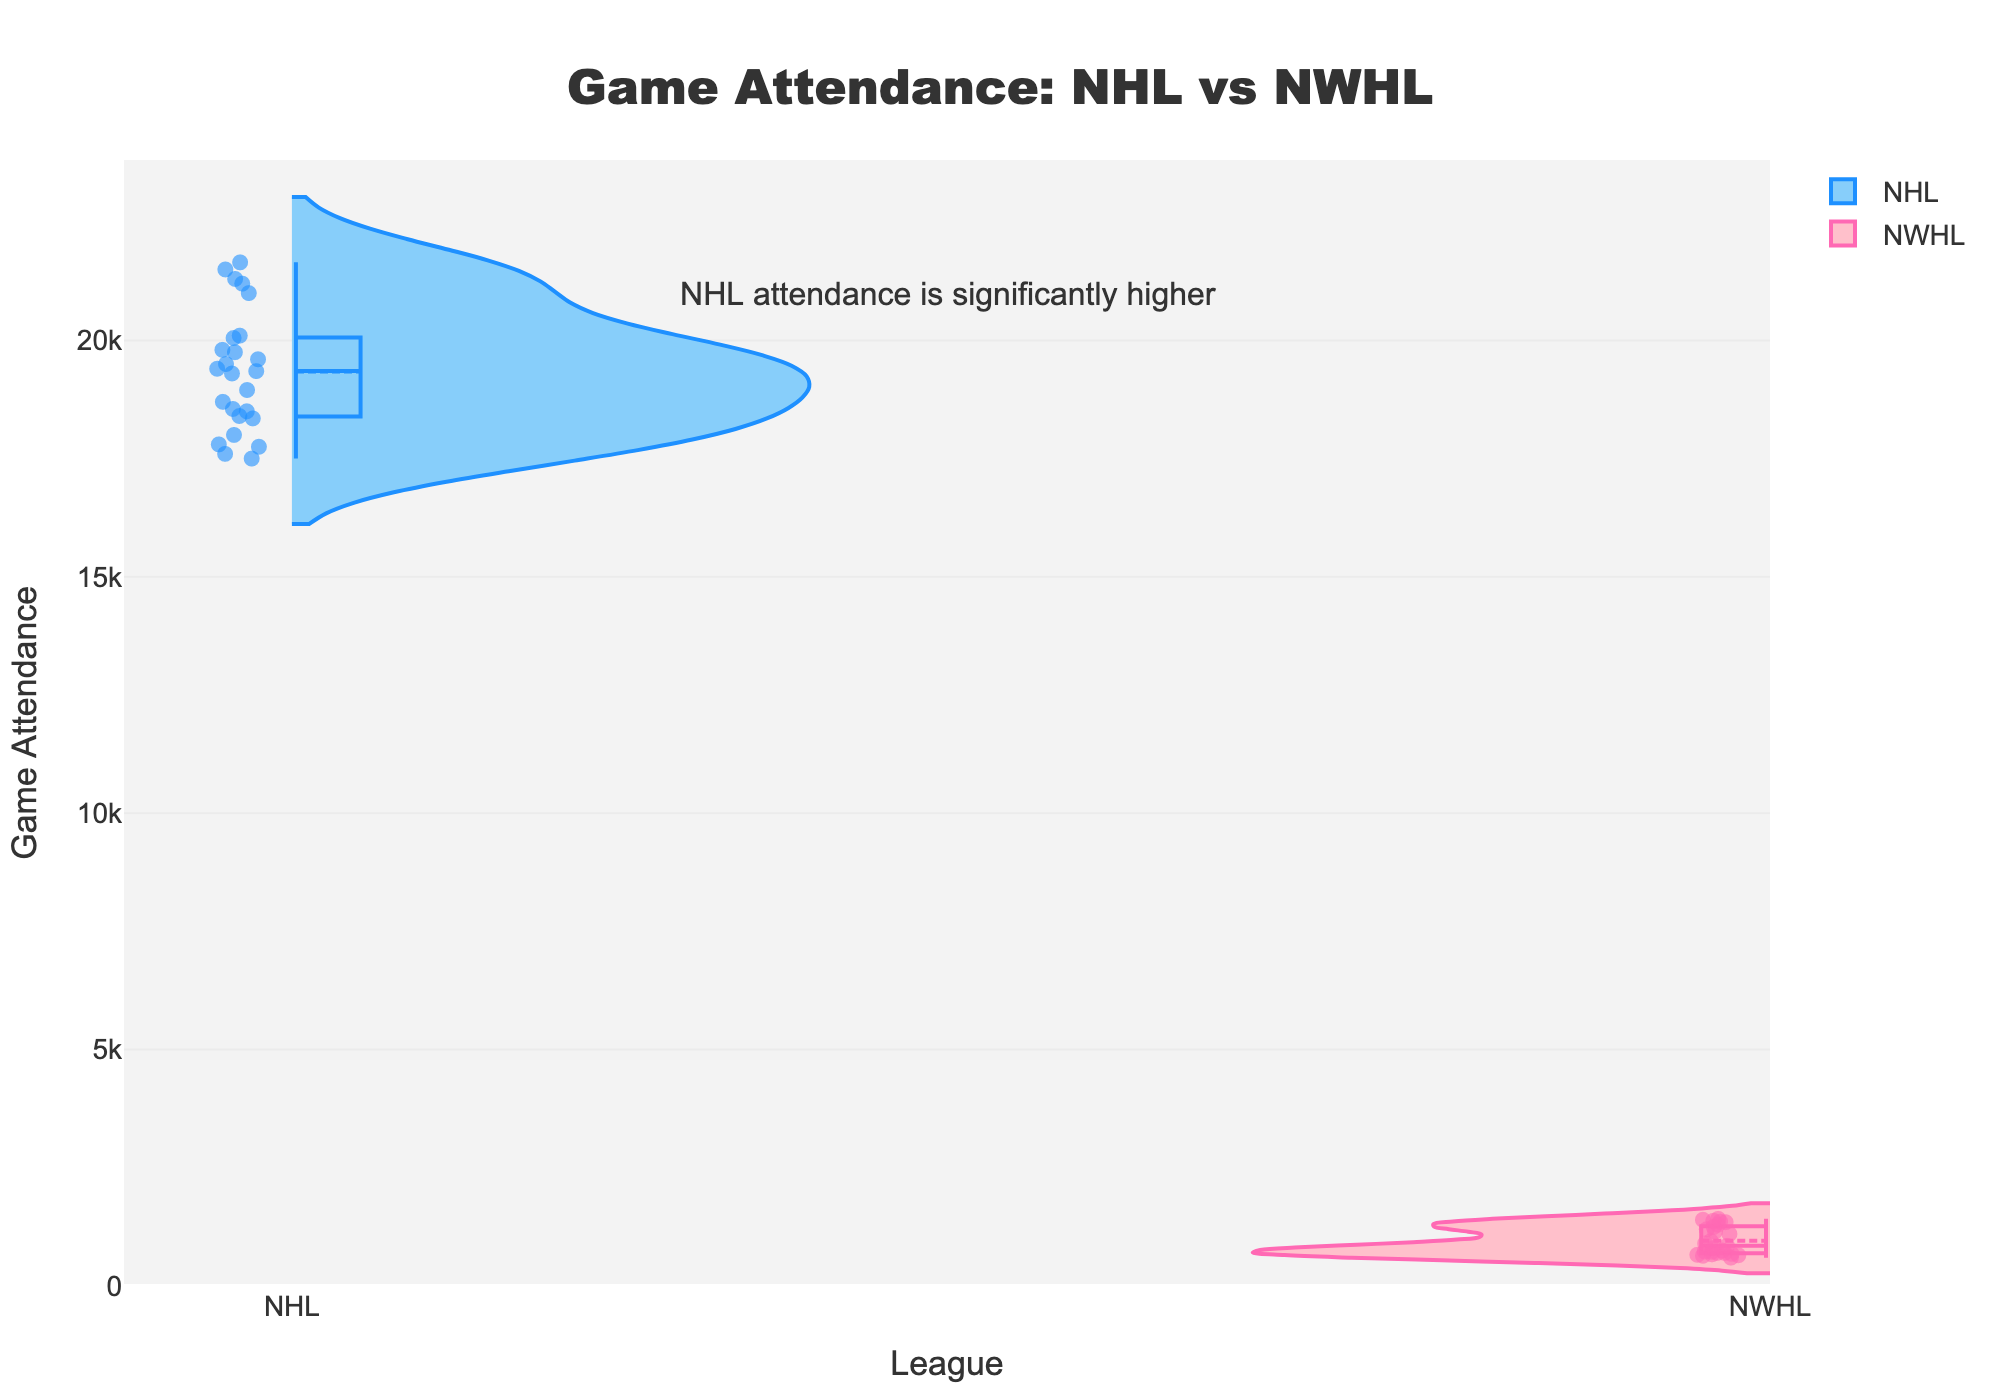How many leagues are being compared in this chart? The chart title and the two separate violin plots indicate there are two different leagues being compared.
Answer: 2 Which league has higher game attendance on average, NHL or NWHL? By looking at the spread and the height of the violin plots, the NHL's attendance figures are higher than those of the NWHL.
Answer: NHL What is the highest game attendance recorded for an NHL game? The highest point on the NHL violin plot represents the maximum attendance for NHL games.
Answer: 21650 What is the approximate range of game attendance figures for the NWHL? The violin plot for the NWHL shows the distribution from the lowest to the highest points, ranging from around 600 to 1420 attendees.
Answer: 600 to 1420 What does the annotation on the chart imply about game attendance? The annotation states that "NHL attendance is significantly higher," indicating that the NHL consistently draws larger crowds compared to the NWHL.
Answer: NHL attendance is significantly higher Are the data points in the plots only showing the distribution of attendance or include other markers? The violin plots include both the distribution of attendance data and individual data points (dots) marked on top of the distribution to indicate specific game attendances.
Answer: Include other markers Is there a difference in the overall spread (variance) of attendance numbers between the NHL and NWHL? The violin plot for the NHL is wider and taller, suggesting a higher variance in game attendance as compared to the more narrow and shorter NWHL plot.
Answer: Yes, there is a difference What can be said about the median attendance numbers for the NHL and NWHL? The violin plots have a meanline and a box which helps to identify median values. The median for the NHL is around the center of its wide and tall distribution, which is much higher than the median of the NWHL's narrow and shorter plot.
Answer: NHL's median is higher How does the attendance distribution for NWHL games compare to that of the NHL games? The NWHL distribution is more compressed and towards the lower end of the attendance scale, whereas the NHL has a broader, taller spread reaching much higher attendance numbers.
Answer: NWHL is more compressed and lower Why is there a colored area within each violin plot? The colored area within each violin plot represents the distribution density of the data points, with wider sections indicating a higher density of data points at those attendance levels.
Answer: To show distribution density 